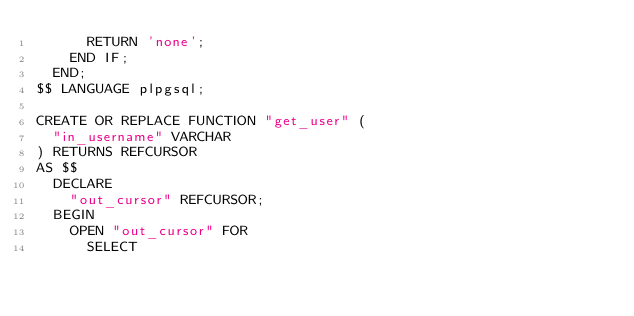<code> <loc_0><loc_0><loc_500><loc_500><_SQL_>      RETURN 'none';
    END IF;
  END;
$$ LANGUAGE plpgsql;

CREATE OR REPLACE FUNCTION "get_user" (
  "in_username" VARCHAR
) RETURNS REFCURSOR
AS $$
  DECLARE
    "out_cursor" REFCURSOR;
  BEGIN
    OPEN "out_cursor" FOR
      SELECT </code> 